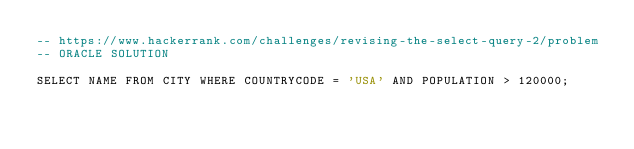Convert code to text. <code><loc_0><loc_0><loc_500><loc_500><_SQL_>-- https://www.hackerrank.com/challenges/revising-the-select-query-2/problem
-- ORACLE SOLUTION

SELECT NAME FROM CITY WHERE COUNTRYCODE = 'USA' AND POPULATION > 120000;
</code> 